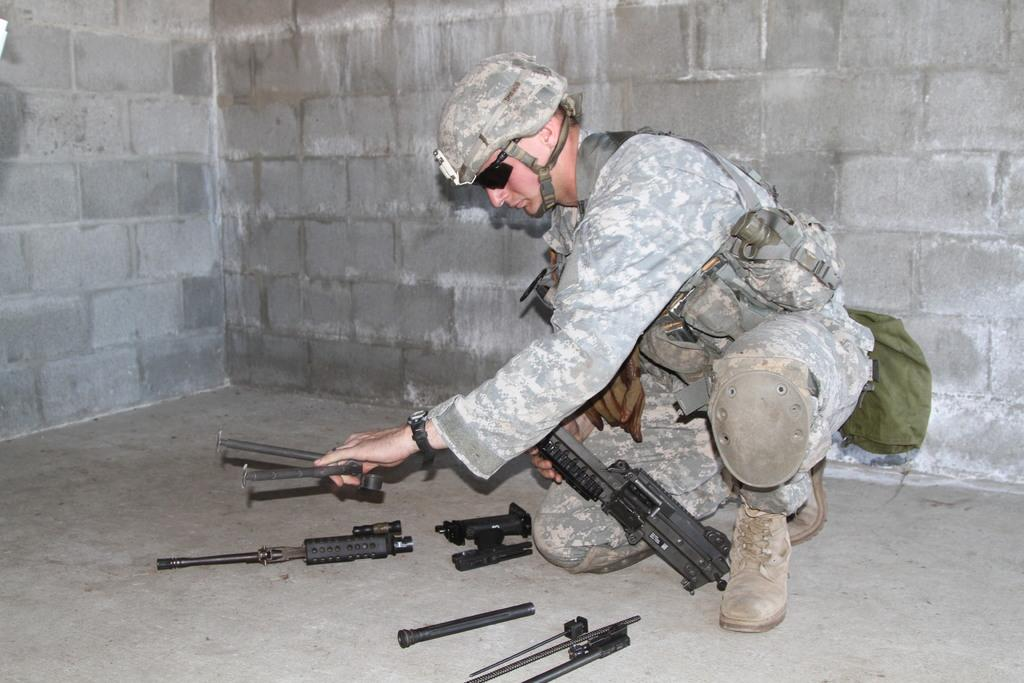What is the main subject of the image? The main subject of the image is a man. What is the man wearing in the image? The man is wearing a uniform and a helmet in the image. Are there any other objects on the man? Yes, there are other objects on the man, such as equipment or tools. What can be seen on the ground in the image? There are objects on the ground in the image. What is visible in the background of the image? There is a wall in the background of the image. What type of poison is the man using in the image? There is no poison present in the image; the man is wearing a uniform and a helmet, and there are no indications of poisonous substances. What kind of shock can be seen affecting the man in the image? There is no shock or electrical discharge present in the image; the man is wearing a uniform and a helmet, and there are no indications of any shock-related incidents. 